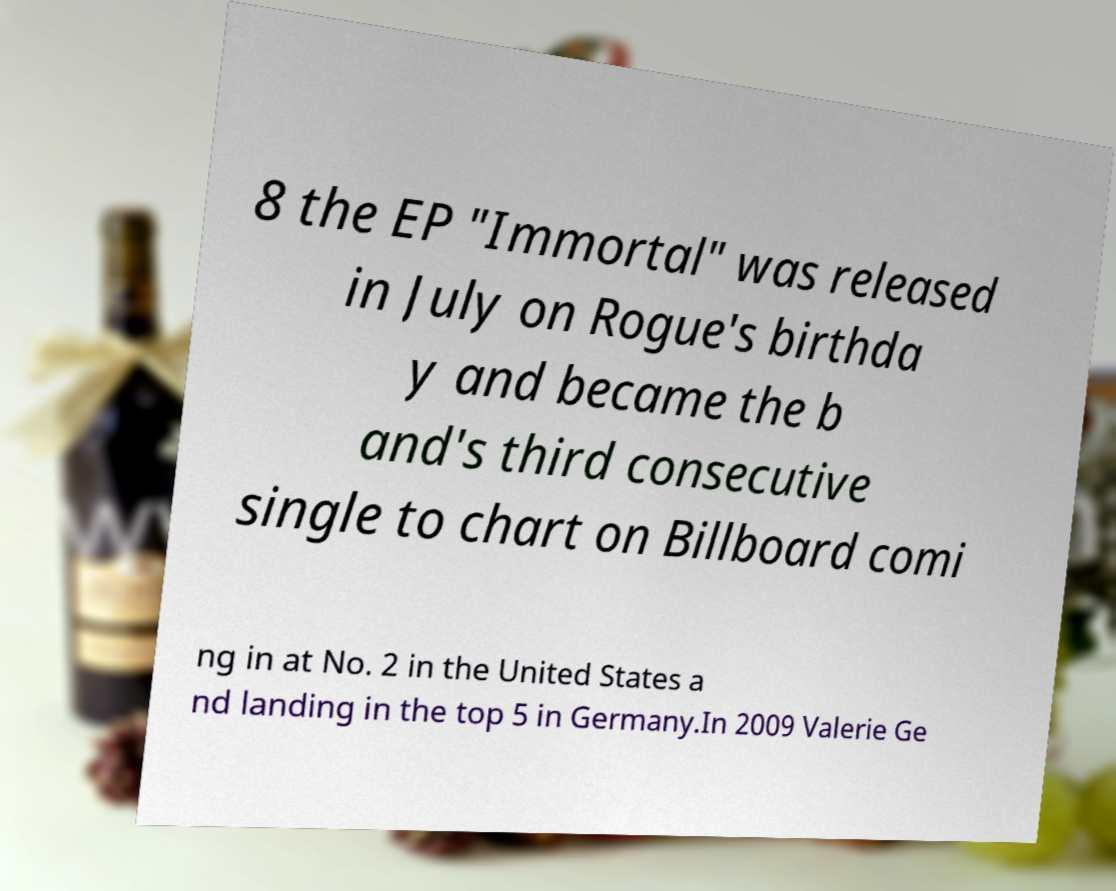I need the written content from this picture converted into text. Can you do that? 8 the EP "Immortal" was released in July on Rogue's birthda y and became the b and's third consecutive single to chart on Billboard comi ng in at No. 2 in the United States a nd landing in the top 5 in Germany.In 2009 Valerie Ge 